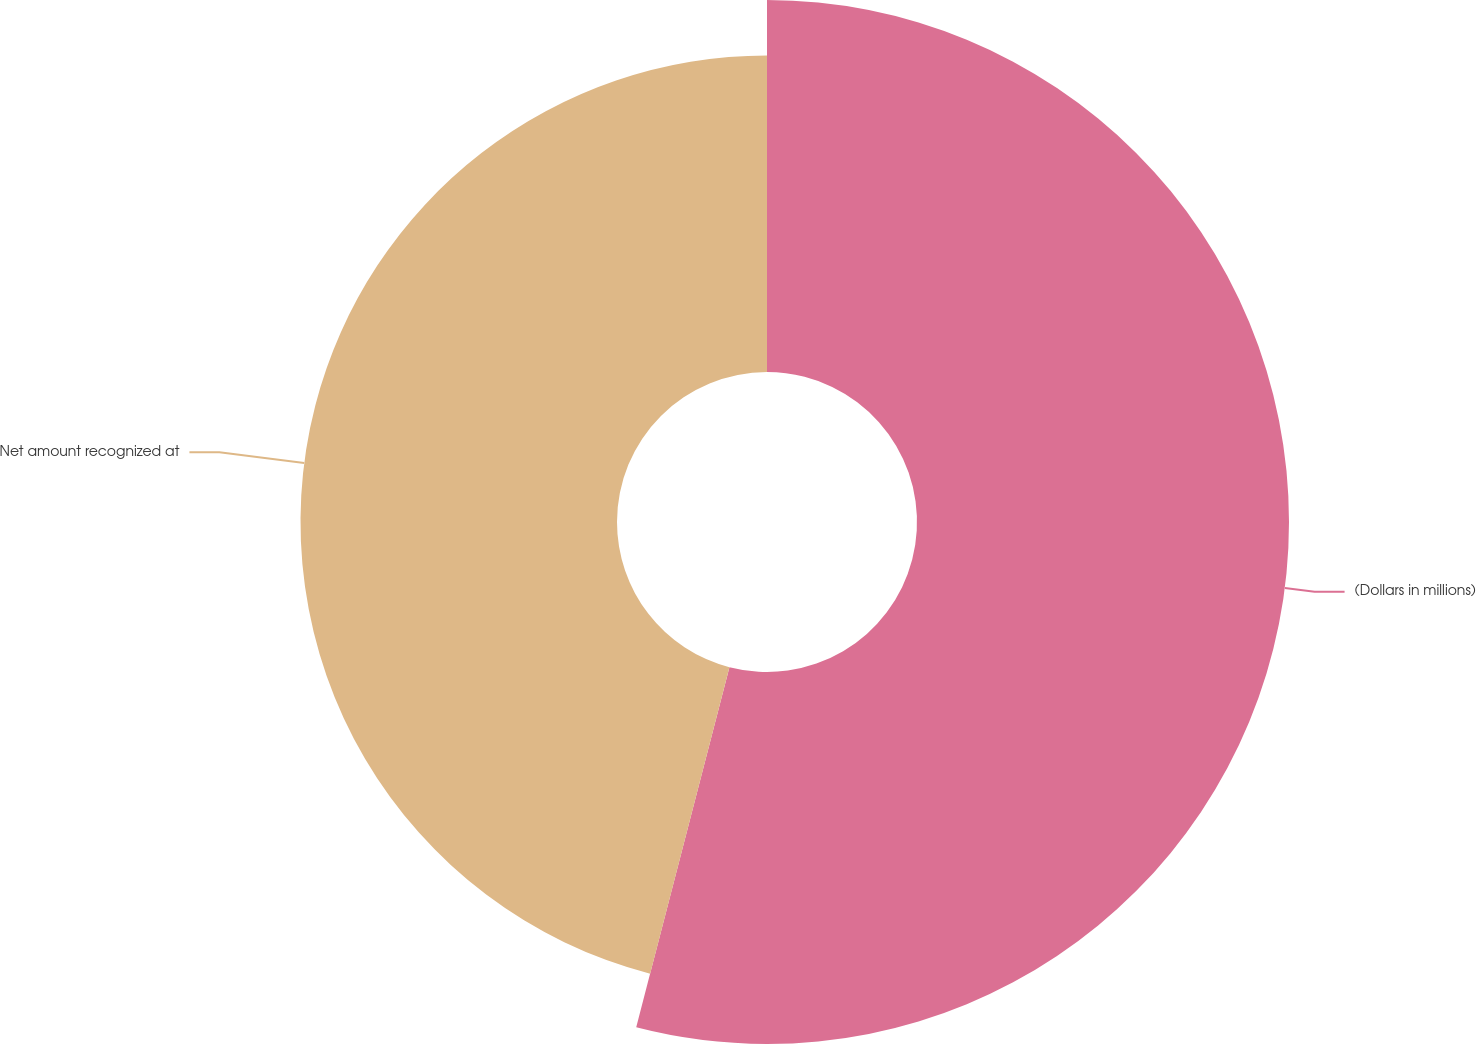Convert chart to OTSL. <chart><loc_0><loc_0><loc_500><loc_500><pie_chart><fcel>(Dollars in millions)<fcel>Net amount recognized at<nl><fcel>54.03%<fcel>45.97%<nl></chart> 